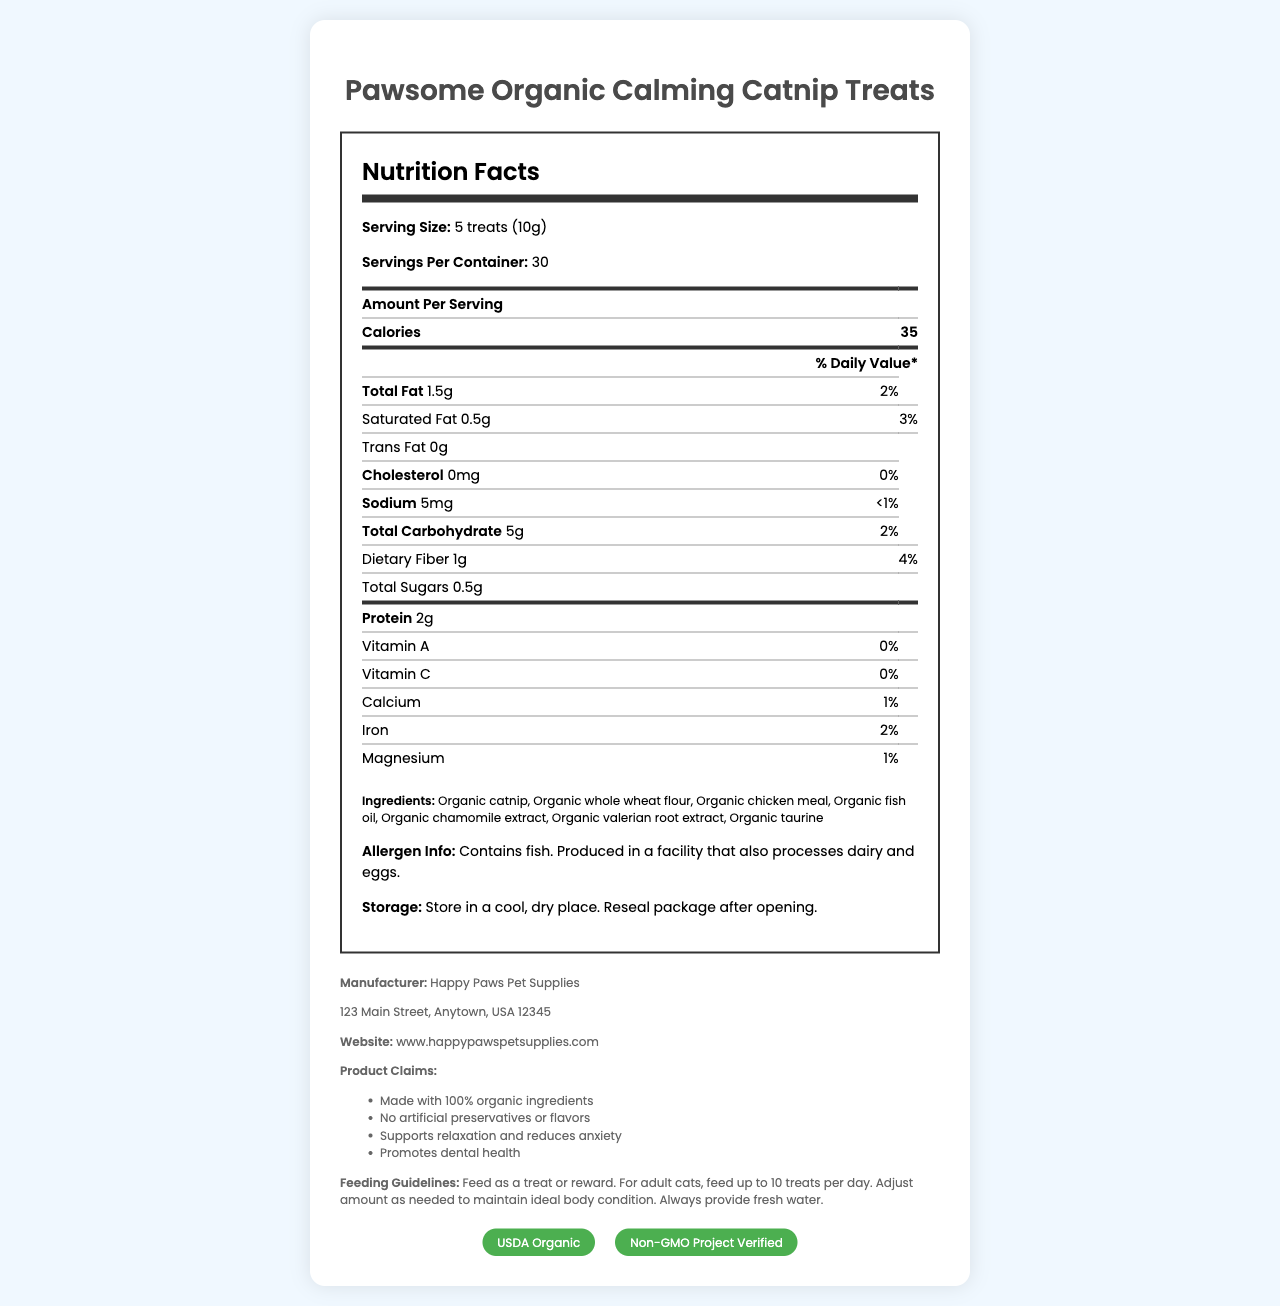what is the serving size of the Pawsome Organic Calming Catnip Treats? The serving size is specified in the document under the Nutrition Facts section as 5 treats (10g).
Answer: 5 treats (10g) How many servings are in one container of these treats? The document states there are 30 servings per container.
Answer: 30 How many calories are there per serving? The calories per serving is listed as 35 calories.
Answer: 35 What is the total fat content per serving? The total fat amount per serving is 1.5g as mentioned in the Nutrition Facts section.
Answer: 1.5g Which company manufactures these catnip treats? The manufacturer's name is given in the document as Happy Paws Pet Supplies.
Answer: Happy Paws Pet Supplies What are the main ingredients in these treats? The ingredients are listed in the document.
Answer: Organic catnip, Organic whole wheat flour, Organic chicken meal, Organic fish oil, Organic chamomile extract, Organic valerian root extract, Organic taurine Does this product contain any allergens? If so, what are they? The allergen info section states that the product contains fish.
Answer: Yes, it contains fish. How much sodium is in each serving? The sodium content per serving is listed as 5mg in the Nutrition Facts.
Answer: 5mg What is the protein content per serving? The protein content per serving is provided as 2g.
Answer: 2g Is this product certified organic? The product has the USDA Organic certification as stated in the certifications section.
Answer: Yes What are the feeding guidelines for adult cats? The feeding guidelines specify feeding up to 10 treats per day for adult cats and provide additional instructions.
Answer: Feed up to 10 treats per day. Adjust amount as needed to maintain ideal body condition. Always provide fresh water. Which of the following is a claim made about the product? A. Contains artificial preservatives B. Supports relaxation and reduces anxiety C. Promotes weight gain D. Made with non-organic ingredients Among the claims listed in the document, one of them is "Supports relaxation and reduces anxiety."
Answer: B What is the daily value percentage of dietary fiber per serving? A. 1% B. 2% C. 4% D. 5% The daily value percentage of dietary fiber per serving is 4%, as mentioned under the Nutrition Facts.
Answer: C Does this product contain any artificial preservatives or flavors? The product claims state that it has no artificial preservatives or flavors.
Answer: No What is the main purpose of this document? The document is structured to offer comprehensive information about the product, including its nutritional content, ingredients, certifications, allergen information, and guidelines for use.
Answer: It provides detailed nutritional information, ingredient list, allergen info, manufacturer details, product claims, and feeding guidelines for Pawsome Organic Calming Catnip Treats. What is the percentage of Vitamin C in this product? The document lists the Vitamin C content as 0% in the Nutrition Facts section.
Answer: 0% Are these treats produced in a facility that processes dairy and eggs? The allergen info section indicates that the product is produced in a facility that also processes dairy and eggs.
Answer: Yes What kind of certifications does this product have? The product has both the USDA Organic and Non-GMO Project Verified certifications as shown in the certifications section.
Answer: USDA Organic, Non-GMO Project Verified How do you store this product after opening? The storage instructions specify to store the product in a cool, dry place and to reseal the package after opening.
Answer: Store in a cool, dry place. Reseal package after opening. What is the exact amount of calcium per serving? The document provides the daily value percentage (1%) but not the exact milligrams of calcium per serving.
Answer: Not enough information 